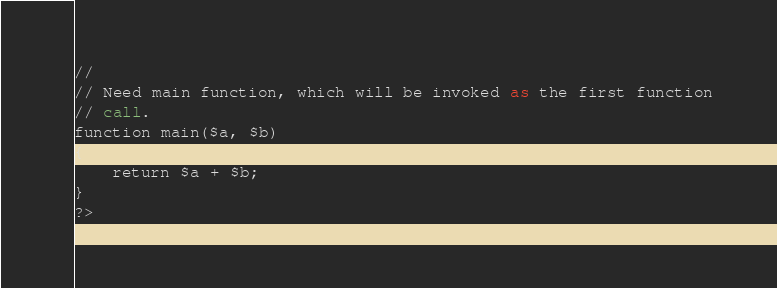<code> <loc_0><loc_0><loc_500><loc_500><_SML_>//
// Need main function, which will be invoked as the first function
// call.
function main($a, $b)
{
    return $a + $b;
}
?>

</code> 